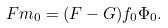Convert formula to latex. <formula><loc_0><loc_0><loc_500><loc_500>F m _ { 0 } = ( F - G ) f _ { 0 } \Phi _ { 0 } .</formula> 